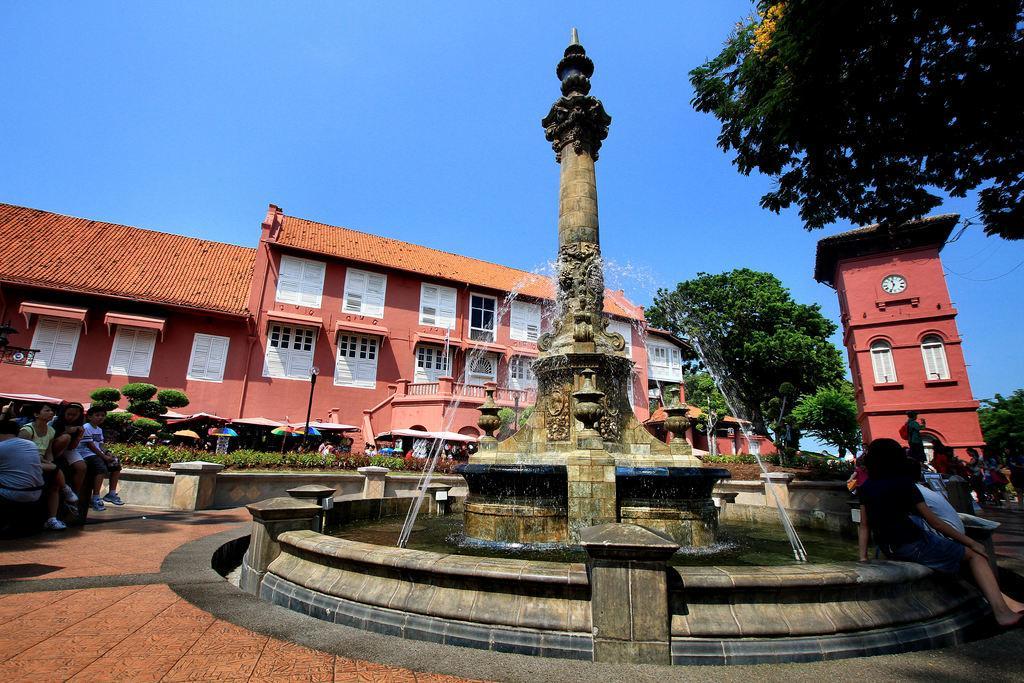Please provide a concise description of this image. In the foreground of the picture we can see people, fountain and path. In the middle of the picture there are buildings, trees, plants, people and various objects. At the top towards right we can see the branch of a tree. At the top there is sky. 